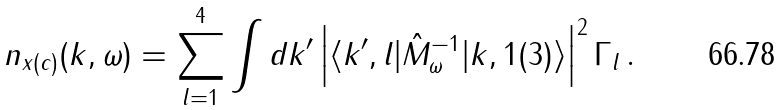<formula> <loc_0><loc_0><loc_500><loc_500>n _ { x ( c ) } ( { k } , \omega ) = \sum _ { l = 1 } ^ { 4 } \int d { k ^ { \prime } } \left | \langle { k ^ { \prime } } , l | \hat { M } _ { \omega } ^ { - 1 } | { k } , 1 ( 3 ) \rangle \right | ^ { 2 } \Gamma _ { l } \, .</formula> 